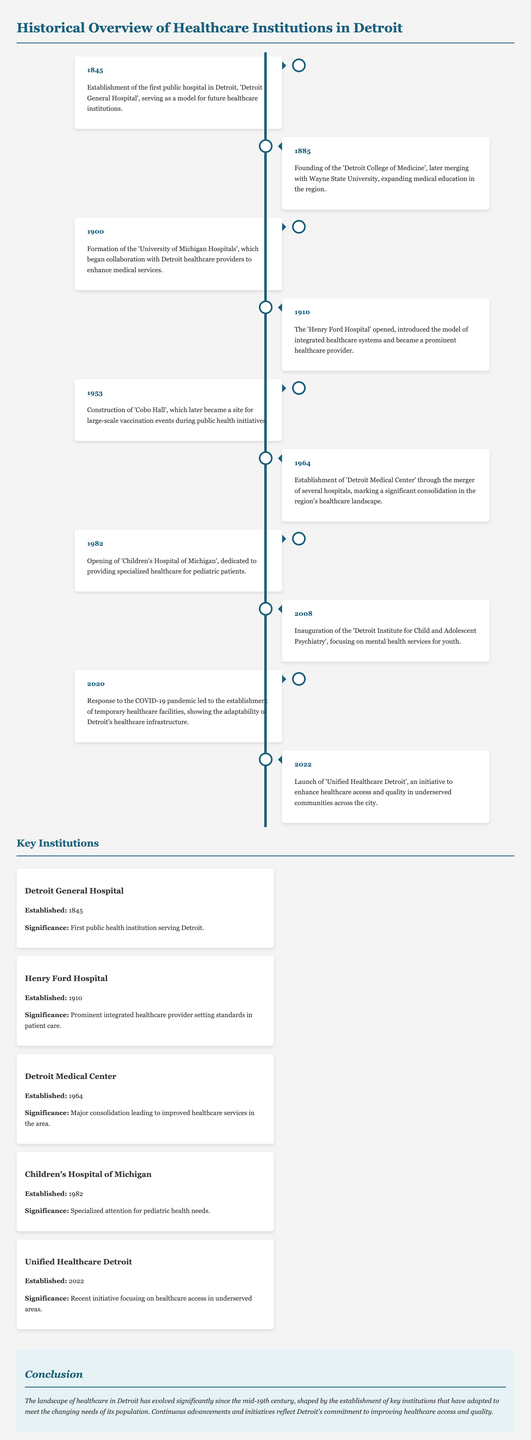what year was the Detroit General Hospital established? The establishment year of the Detroit General Hospital is mentioned in the timeline.
Answer: 1845 which institution was founded in 1885? The timeline states that the Detroit College of Medicine was founded in 1885.
Answer: Detroit College of Medicine what significant healthcare facility opened in 1910? The timeline indicates that the Henry Ford Hospital opened in 1910.
Answer: Henry Ford Hospital what major healthcare initiative was launched in 2022? According to the document, the Unified Healthcare Detroit initiative was launched in 2022.
Answer: Unified Healthcare Detroit how many significant milestones are listed in the document? The milestones listed in the timeline comprise the key developments in the history of healthcare in Detroit. There are ten milestones provided.
Answer: 10 which hospital specialized in pediatric care and opened in 1982? The document specifically mentions that Children's Hospital of Michigan opened in 1982 for pediatric patients.
Answer: Children's Hospital of Michigan what was the main purpose of Cobo Hall after its construction in 1953? The document states that Cobo Hall became a site for large-scale vaccination events during public health initiatives.
Answer: Vaccination events which year marks the response to the COVID-19 pandemic in healthcare adaptation? The timeline references the year 2020 as significant for establishing temporary healthcare facilities in response to the COVID-19 pandemic.
Answer: 2020 what pattern is observed in the timeline structure? The timeline alternates left and right placement for each milestone, visually separating events for clarity.
Answer: Alternating placement 